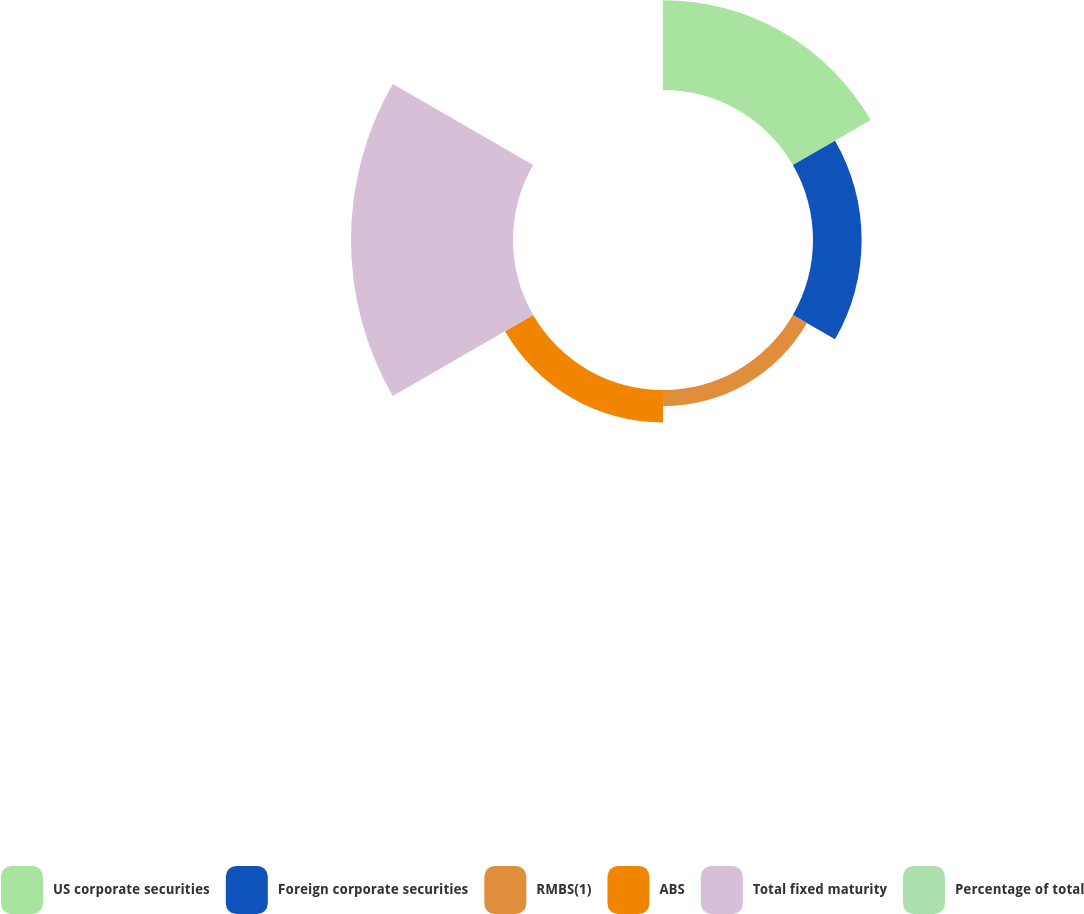Convert chart to OTSL. <chart><loc_0><loc_0><loc_500><loc_500><pie_chart><fcel>US corporate securities<fcel>Foreign corporate securities<fcel>RMBS(1)<fcel>ABS<fcel>Total fixed maturity<fcel>Percentage of total<nl><fcel>25.72%<fcel>13.93%<fcel>4.65%<fcel>9.29%<fcel>46.39%<fcel>0.01%<nl></chart> 